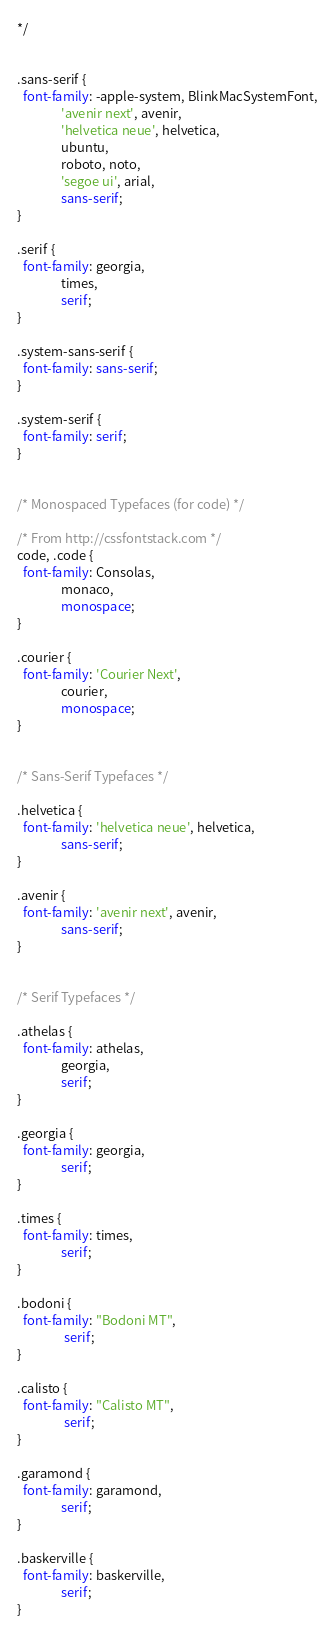<code> <loc_0><loc_0><loc_500><loc_500><_CSS_>
*/


.sans-serif {
  font-family: -apple-system, BlinkMacSystemFont,
               'avenir next', avenir,
               'helvetica neue', helvetica,
               ubuntu,
               roboto, noto,
               'segoe ui', arial,
               sans-serif;
}

.serif {
  font-family: georgia,
               times,
               serif;
}

.system-sans-serif {
  font-family: sans-serif;
}

.system-serif {
  font-family: serif;
}


/* Monospaced Typefaces (for code) */

/* From http://cssfontstack.com */
code, .code {
  font-family: Consolas,
               monaco,
               monospace;
}

.courier {
  font-family: 'Courier Next',
               courier,
               monospace;
}


/* Sans-Serif Typefaces */

.helvetica {
  font-family: 'helvetica neue', helvetica,
               sans-serif;
}

.avenir {
  font-family: 'avenir next', avenir,
               sans-serif;
}


/* Serif Typefaces */

.athelas {
  font-family: athelas,
               georgia,
               serif;
}

.georgia {
  font-family: georgia,
               serif;
}

.times {
  font-family: times,
               serif;
}

.bodoni {
  font-family: "Bodoni MT",
                serif;
}

.calisto {
  font-family: "Calisto MT",
                serif;
}

.garamond {
  font-family: garamond,
               serif;
}

.baskerville {
  font-family: baskerville,
               serif;
}

</code> 